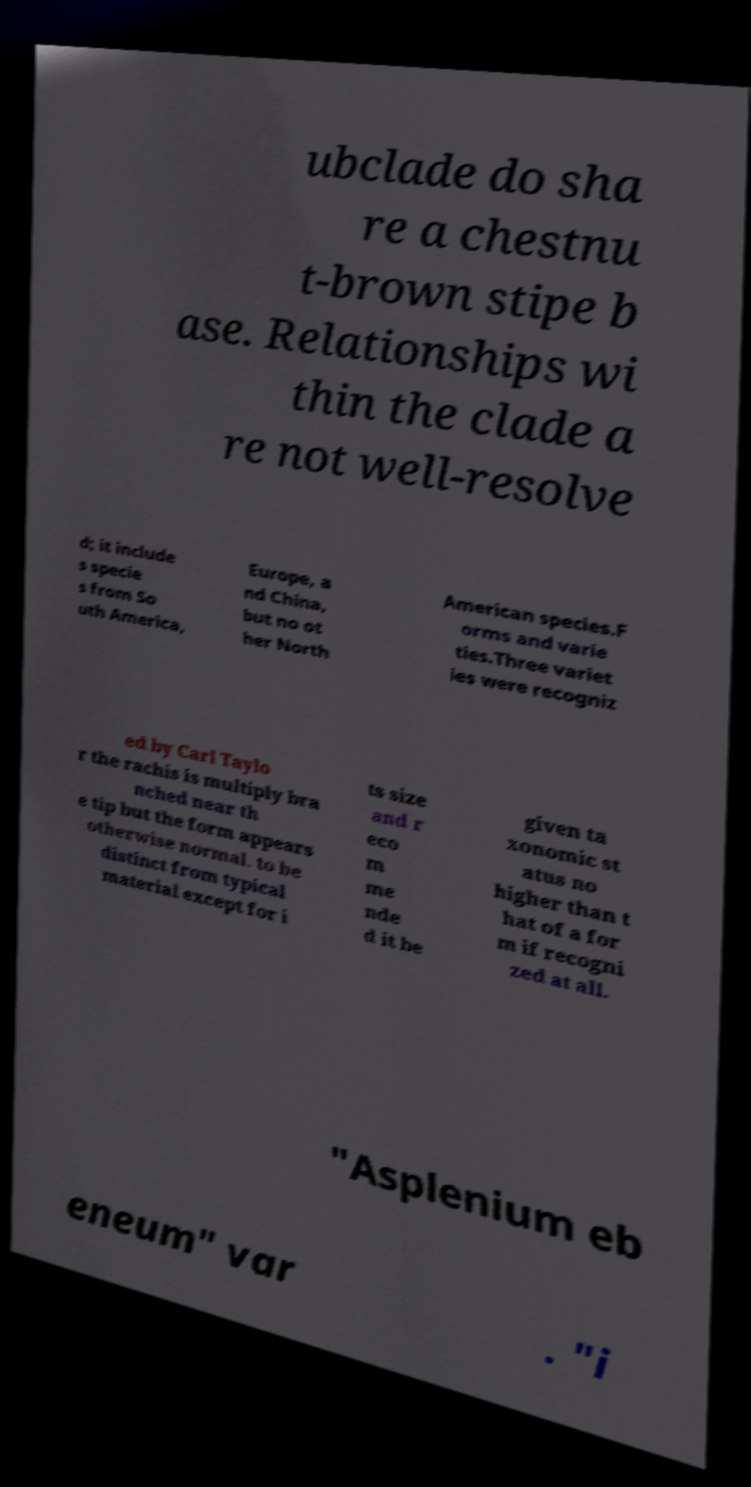Could you extract and type out the text from this image? ubclade do sha re a chestnu t-brown stipe b ase. Relationships wi thin the clade a re not well-resolve d; it include s specie s from So uth America, Europe, a nd China, but no ot her North American species.F orms and varie ties.Three variet ies were recogniz ed by Carl Taylo r the rachis is multiply bra nched near th e tip but the form appears otherwise normal. to be distinct from typical material except for i ts size and r eco m me nde d it be given ta xonomic st atus no higher than t hat of a for m if recogni zed at all. "Asplenium eb eneum" var . "i 